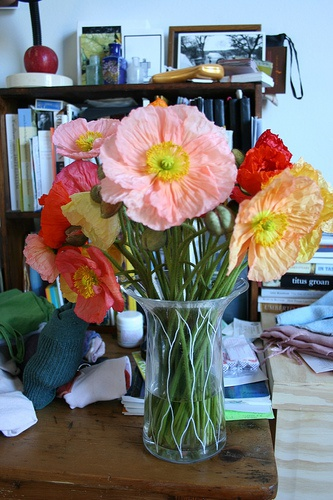Describe the objects in this image and their specific colors. I can see vase in black, darkgreen, teal, and gray tones, book in black, navy, blue, and gray tones, book in black, gray, darkgray, and lightblue tones, book in black, lightblue, and darkgray tones, and book in black, lightblue, and blue tones in this image. 